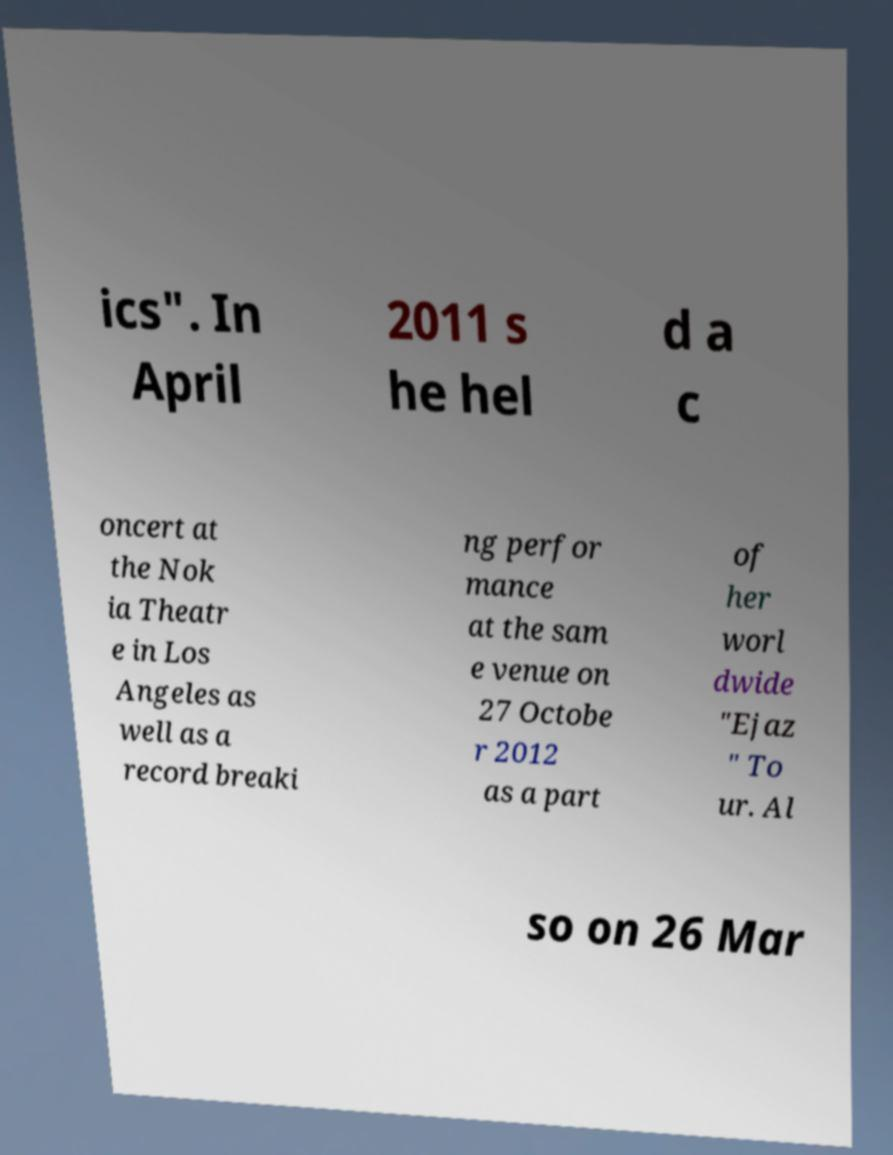For documentation purposes, I need the text within this image transcribed. Could you provide that? ics". In April 2011 s he hel d a c oncert at the Nok ia Theatr e in Los Angeles as well as a record breaki ng perfor mance at the sam e venue on 27 Octobe r 2012 as a part of her worl dwide "Ejaz " To ur. Al so on 26 Mar 